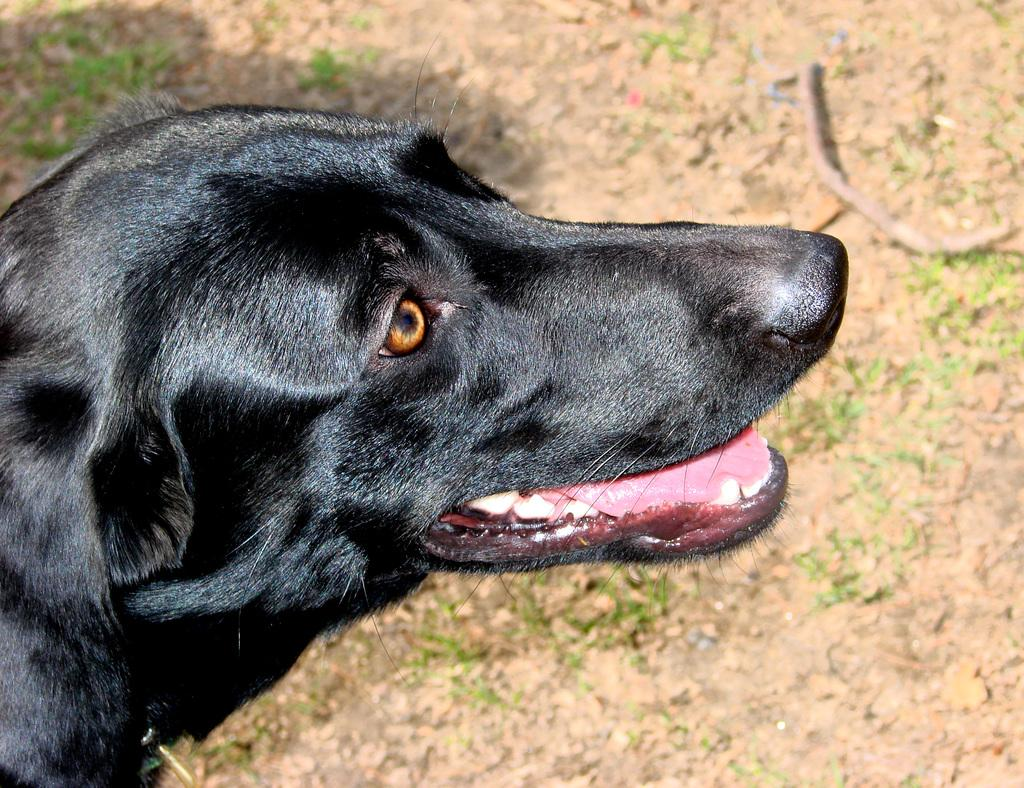What animal is present in the image? There is a dog in the picture. Where is the dog located in the image? The dog is towards the left side of the image. What is the color of the dog? The dog is black in color. How many dolls are being held by the fireman in the image? There is no fireman or dolls present in the image; it features a black dog towards the left side. 